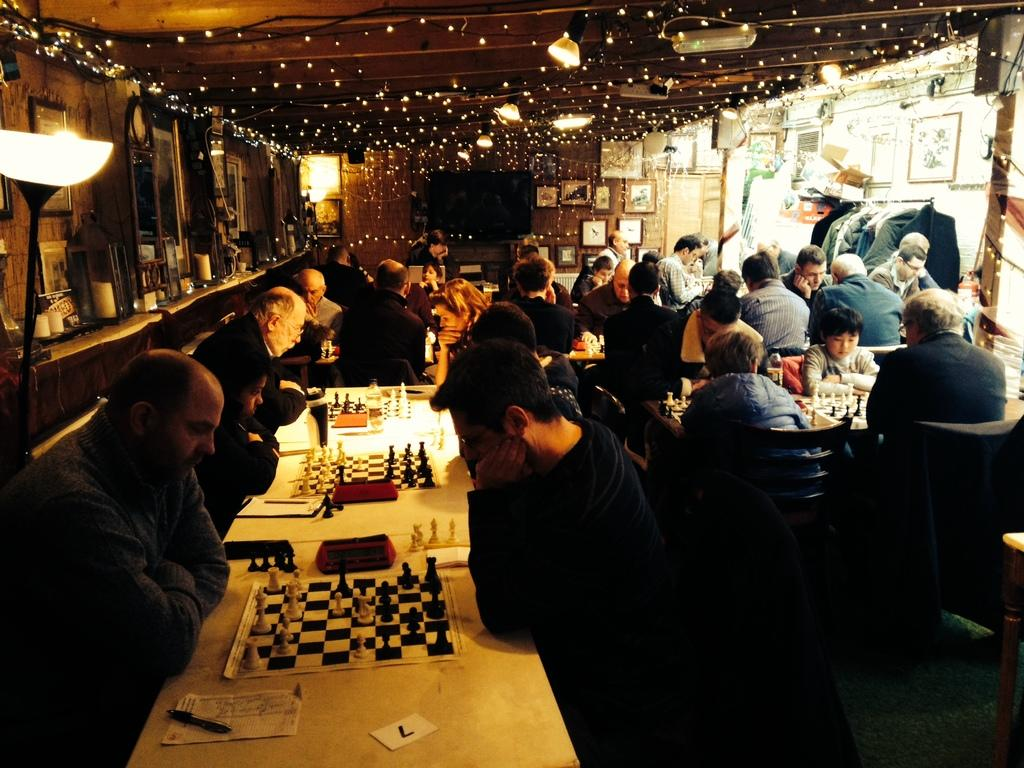What activity are the group of people engaged in? The group of people are playing chess. How are the people interacting with each other during this activity? The people are playing together. What can be seen at the top of the image? There are lights at the top of the image. What type of knife is being used by the players during the game? There is no knife present in the image; the people are playing chess using chess pieces. How many feet are visible in the image? The number of feet visible in the image cannot be determined from the provided facts, as the focus is on the people playing chess and the lights at the top of the image. 